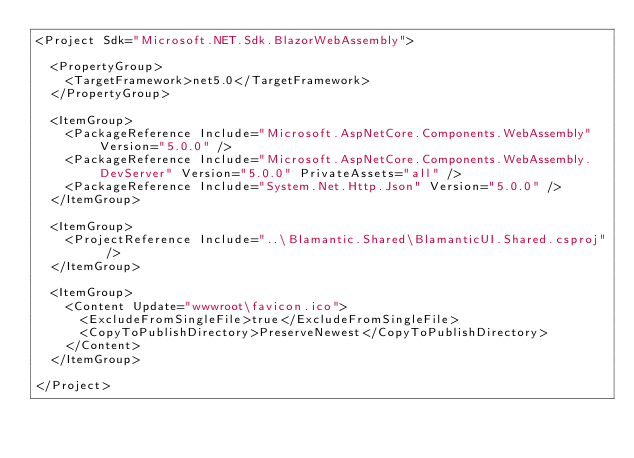<code> <loc_0><loc_0><loc_500><loc_500><_XML_><Project Sdk="Microsoft.NET.Sdk.BlazorWebAssembly">

  <PropertyGroup>
    <TargetFramework>net5.0</TargetFramework>
  </PropertyGroup>

  <ItemGroup>
    <PackageReference Include="Microsoft.AspNetCore.Components.WebAssembly" Version="5.0.0" />
    <PackageReference Include="Microsoft.AspNetCore.Components.WebAssembly.DevServer" Version="5.0.0" PrivateAssets="all" />
    <PackageReference Include="System.Net.Http.Json" Version="5.0.0" />
  </ItemGroup>

  <ItemGroup>
    <ProjectReference Include="..\Blamantic.Shared\BlamanticUI.Shared.csproj" />
  </ItemGroup>

  <ItemGroup>
    <Content Update="wwwroot\favicon.ico">
      <ExcludeFromSingleFile>true</ExcludeFromSingleFile>
      <CopyToPublishDirectory>PreserveNewest</CopyToPublishDirectory>
    </Content>
  </ItemGroup>

</Project>
</code> 